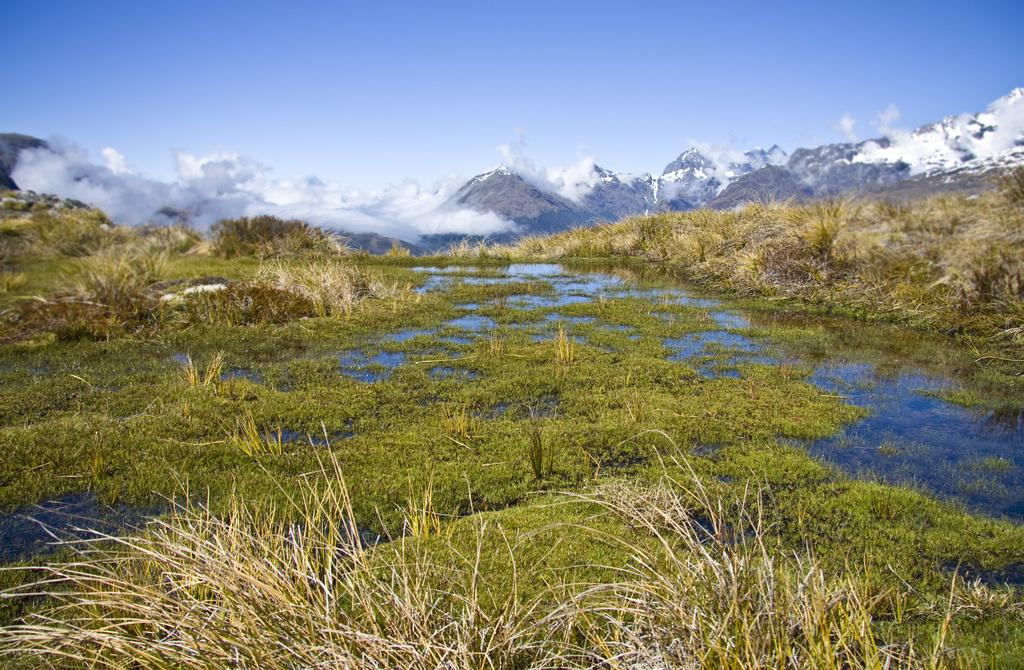What type of natural landform can be seen in the image? There are mountains in the image. What type of vegetation is present in the image? There are plants and grass in the image. What body of water is visible in the image? There is water visible in the image. What part of the natural environment is visible in the image? The sky is visible at the top of the image. How many babies are playing with sticks in the water in the image? There are no babies or sticks present in the image. What type of precipitation can be seen falling from the sky in the image? There is no precipitation visible in the image; it only shows mountains, plants, grass, water, and the sky. 